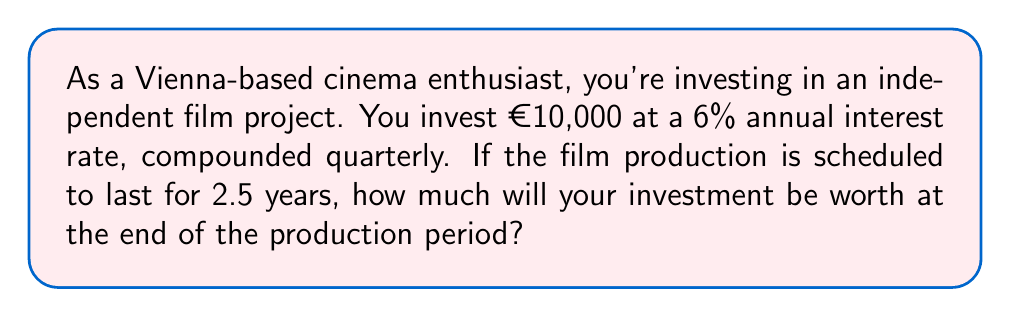Teach me how to tackle this problem. Let's break this down step-by-step using the compound interest formula:

$$A = P(1 + \frac{r}{n})^{nt}$$

Where:
$A$ = Final amount
$P$ = Principal (initial investment)
$r$ = Annual interest rate (as a decimal)
$n$ = Number of times interest is compounded per year
$t$ = Number of years

Given:
$P = €10,000$
$r = 0.06$ (6% as a decimal)
$n = 4$ (compounded quarterly)
$t = 2.5$ years

Let's substitute these values into the formula:

$$A = 10000(1 + \frac{0.06}{4})^{4(2.5)}$$

$$A = 10000(1 + 0.015)^{10}$$

$$A = 10000(1.015)^{10}$$

Now, let's calculate $(1.015)^{10}$:

$$(1.015)^{10} \approx 1.1605$$

Therefore:

$$A = 10000 \times 1.1605 \approx 11605$$
Answer: €11,605 (rounded to the nearest euro) 